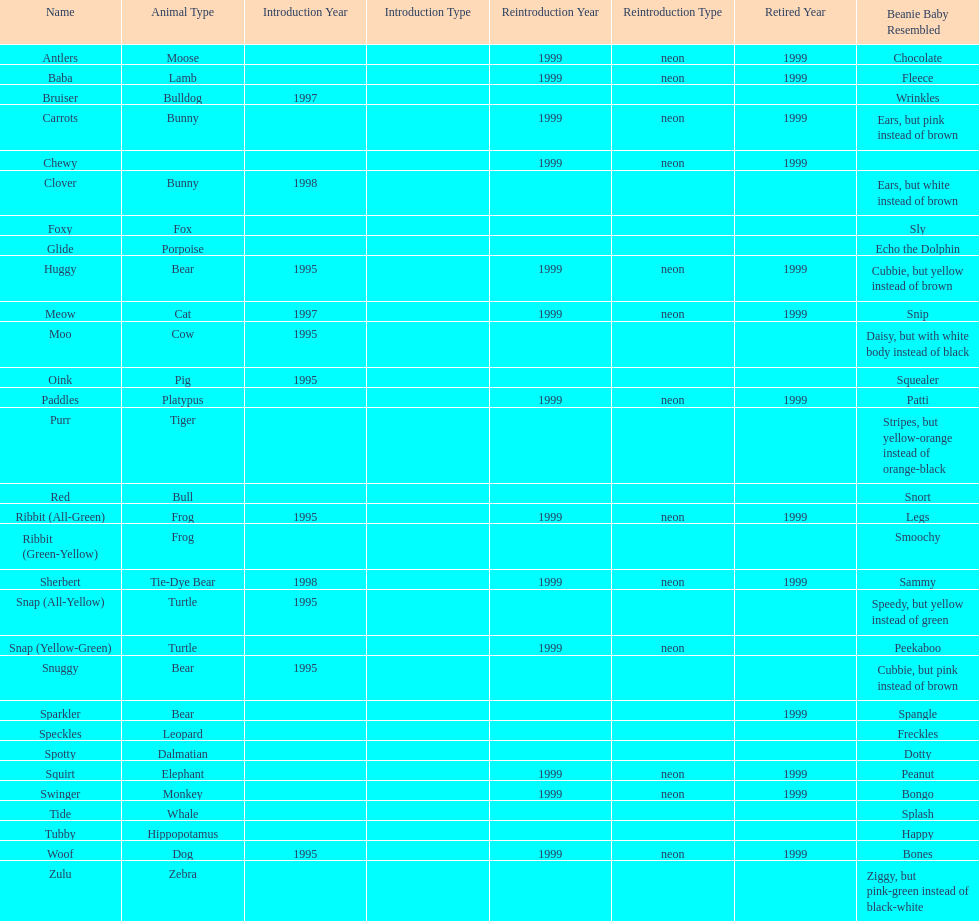What is the total number of pillow pals that were reintroduced as a neon variety? 13. 